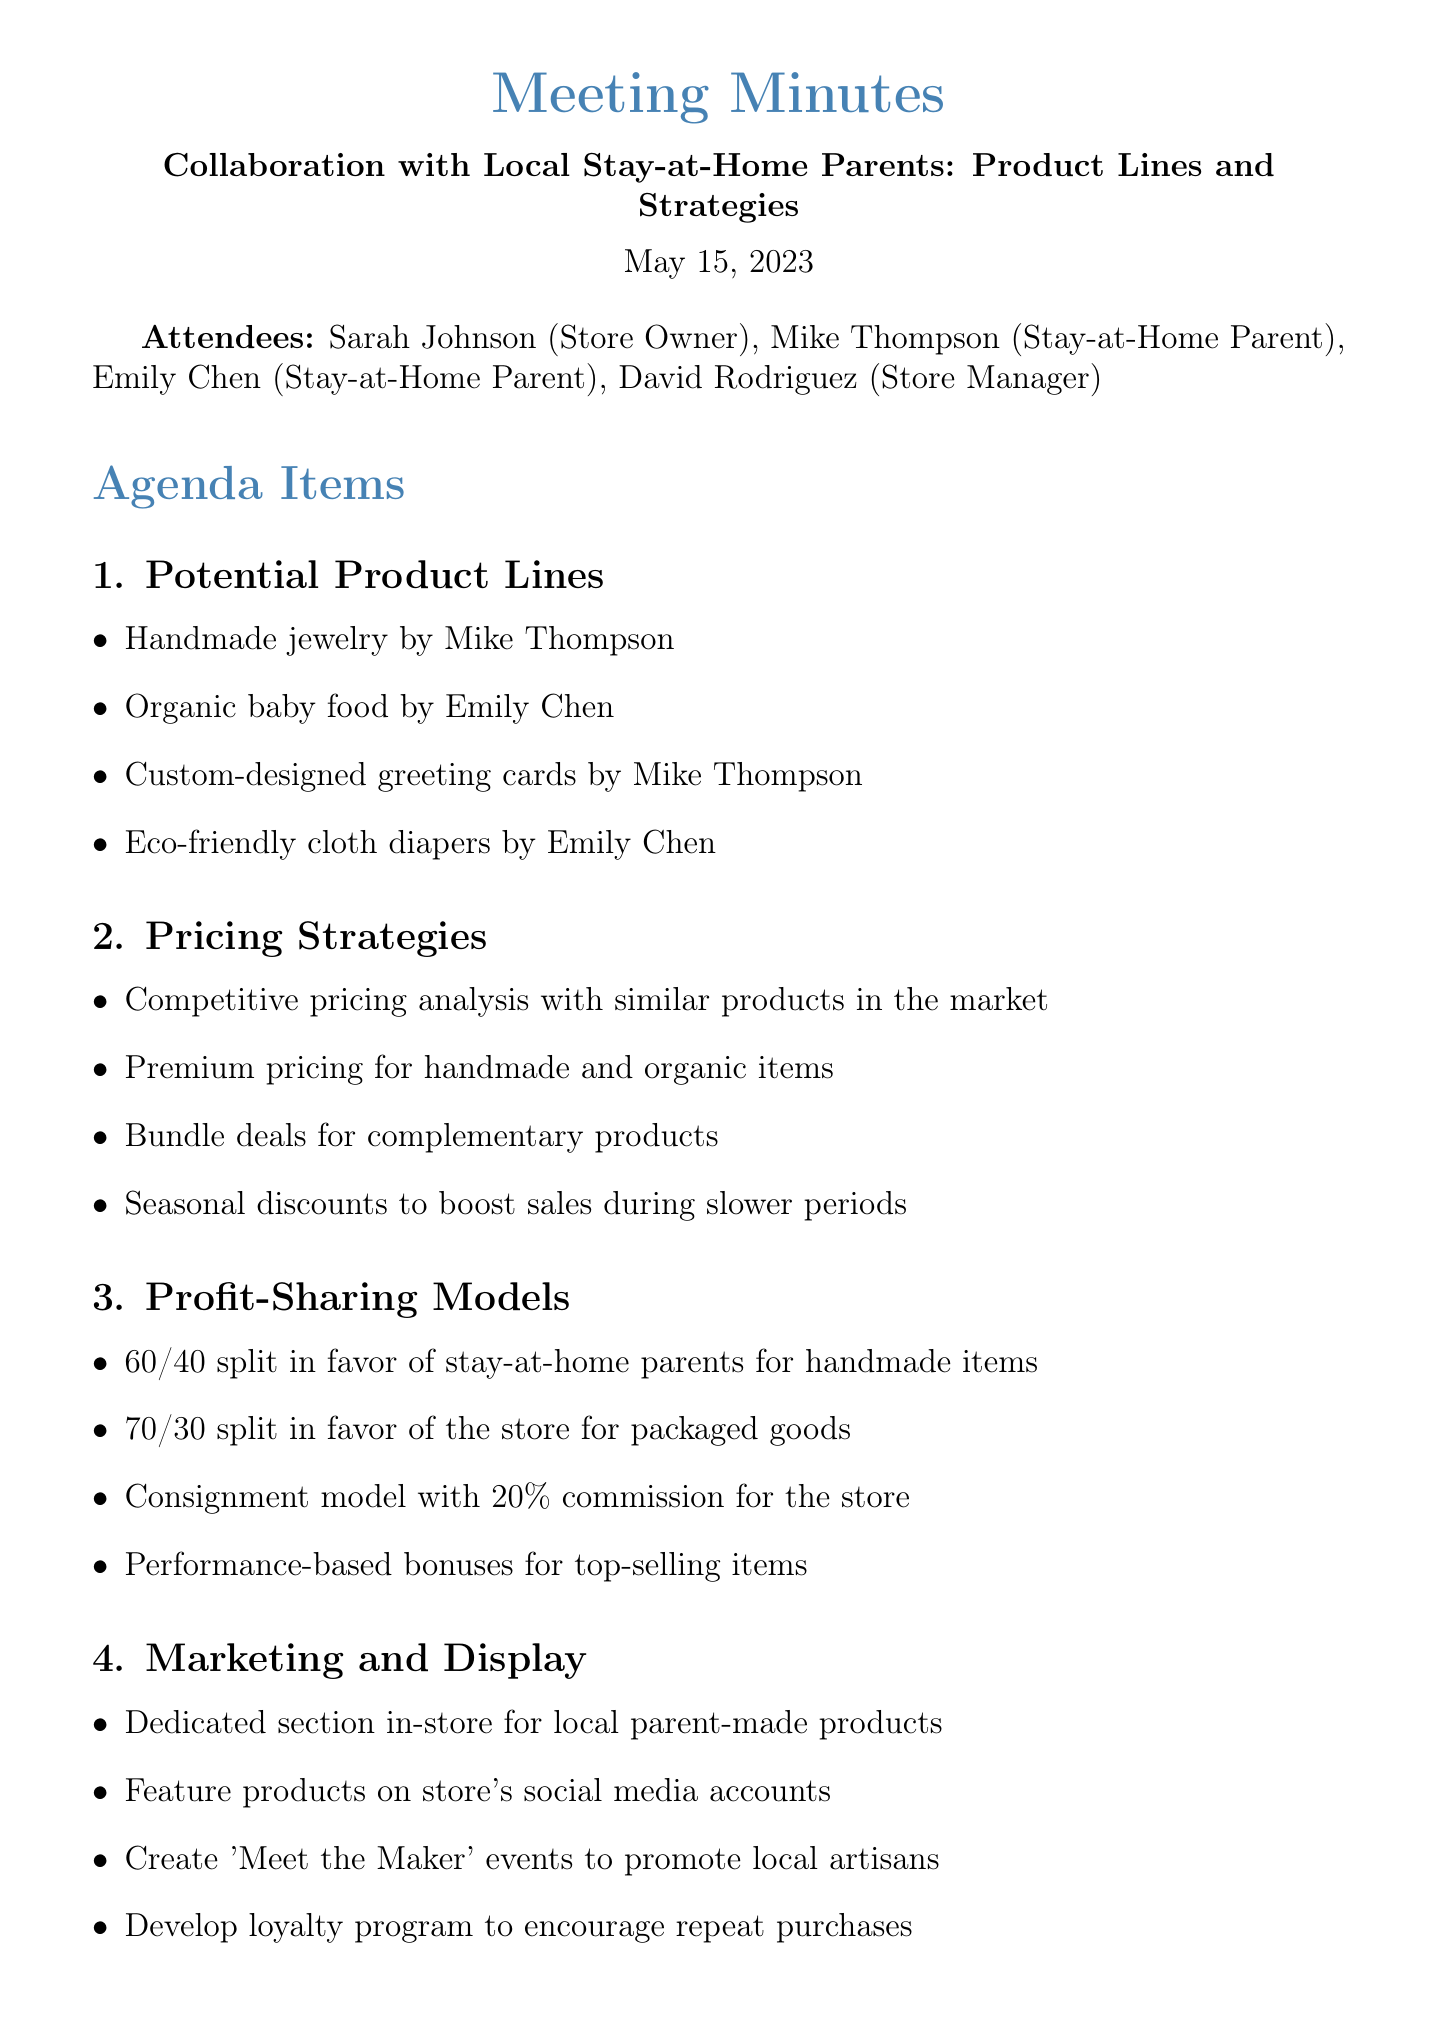What is the meeting date? The meeting date is mentioned at the beginning of the document.
Answer: May 15, 2023 Who is the store owner? The store owner is listed among the attendees at the start of the document.
Answer: Sarah Johnson What product line does Mike Thompson create? Product lines created by Mike Thompson are outlined in the potential product lines section.
Answer: Handmade jewelry What is the profit-sharing split for handmade items? The document specifies the profit-sharing model for handmade items under profit-sharing models.
Answer: 60/40 split What is one marketing strategy mentioned? The marketing strategies are outlined in the marketing and display section.
Answer: Dedicated section in-store for local parent-made products How many action items are listed under next steps? The next steps section includes a list of action items to be taken after the meeting.
Answer: Four action items What items did Emily Chen propose to sell? The potential product lines include products proposed by Emily Chen, which are listed in the discussion points.
Answer: Organic baby food, Eco-friendly cloth diapers What is the consignment commission percentage for the store? The profit-sharing models detail the commission percentage for the store under the consignment model.
Answer: 20 percent When is the follow-up meeting scheduled? The next steps section mentions that there will be a follow-up meeting to finalize details.
Answer: In two weeks 